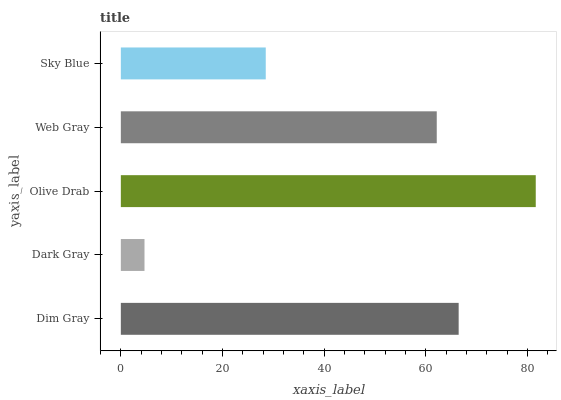Is Dark Gray the minimum?
Answer yes or no. Yes. Is Olive Drab the maximum?
Answer yes or no. Yes. Is Olive Drab the minimum?
Answer yes or no. No. Is Dark Gray the maximum?
Answer yes or no. No. Is Olive Drab greater than Dark Gray?
Answer yes or no. Yes. Is Dark Gray less than Olive Drab?
Answer yes or no. Yes. Is Dark Gray greater than Olive Drab?
Answer yes or no. No. Is Olive Drab less than Dark Gray?
Answer yes or no. No. Is Web Gray the high median?
Answer yes or no. Yes. Is Web Gray the low median?
Answer yes or no. Yes. Is Sky Blue the high median?
Answer yes or no. No. Is Sky Blue the low median?
Answer yes or no. No. 